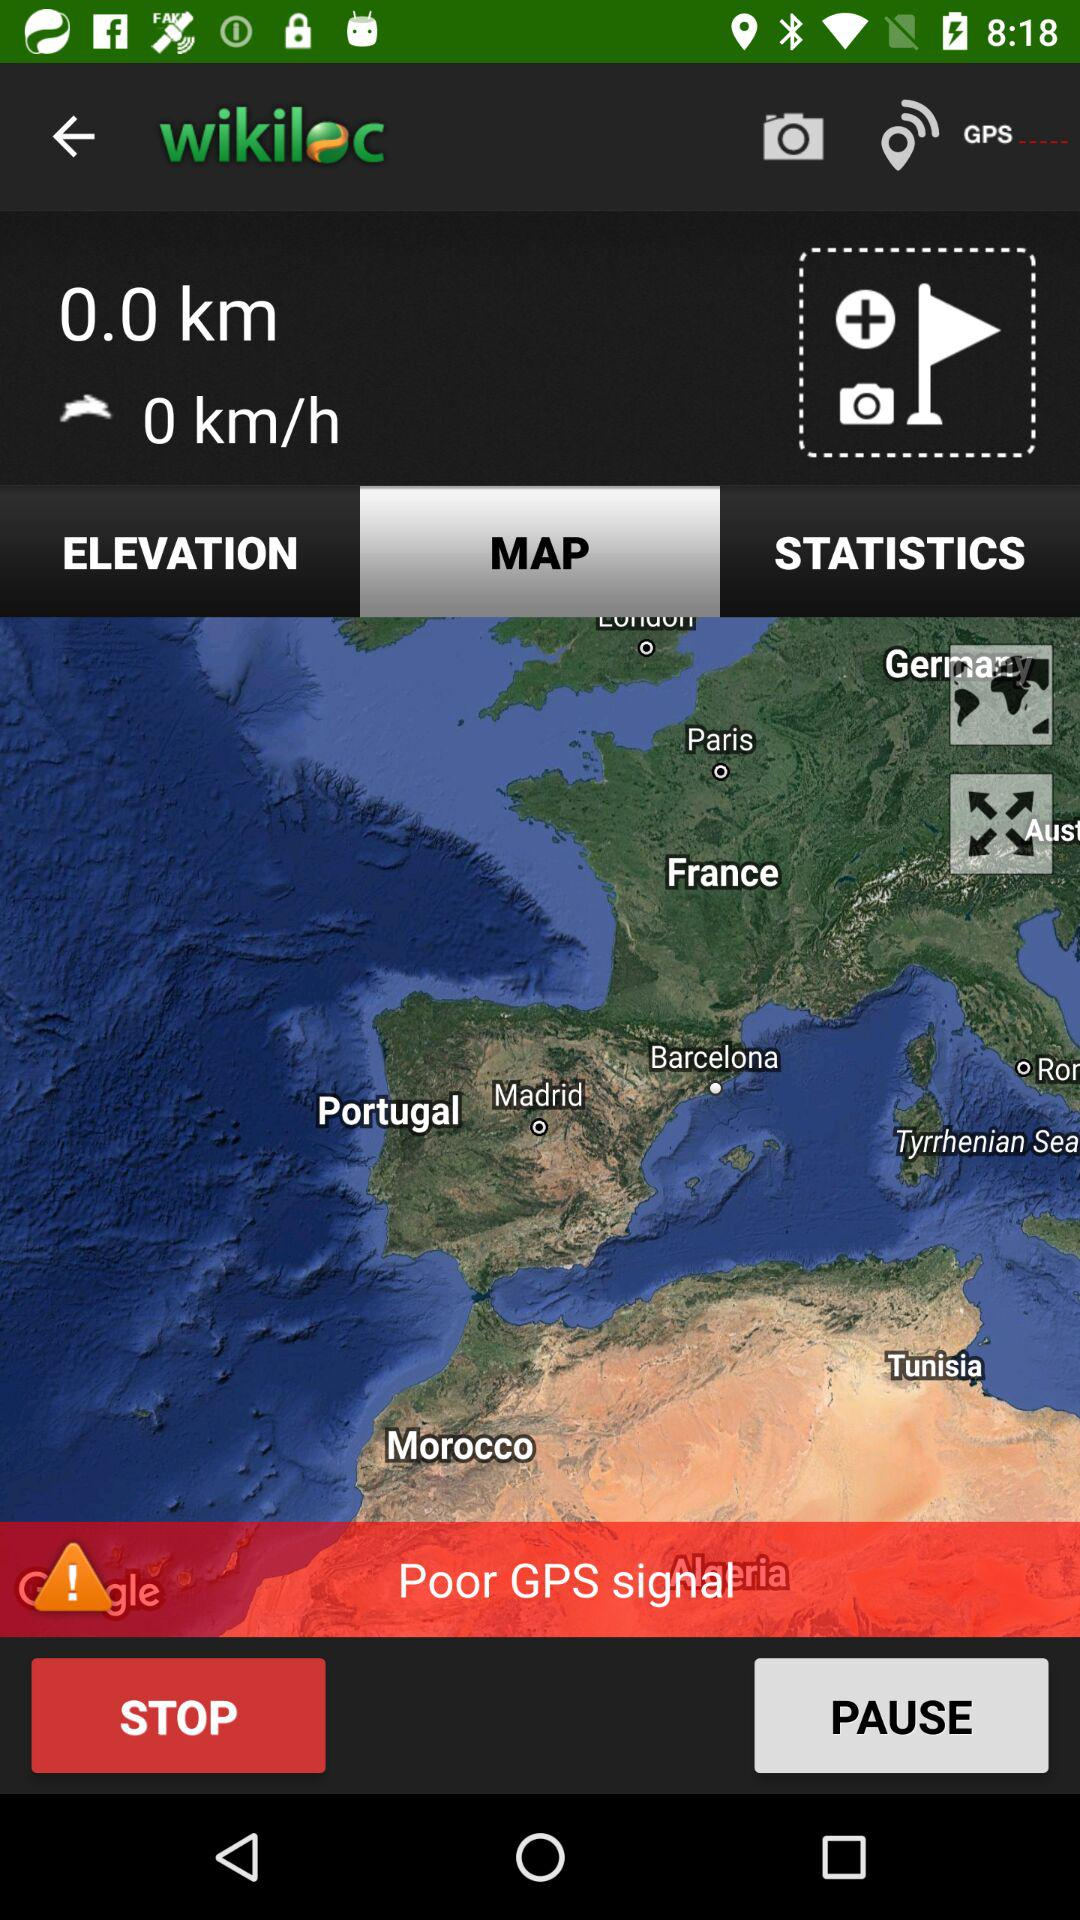What's the number of km per hour? The number of km per hour is 0. 